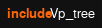Convert code to text. <code><loc_0><loc_0><loc_500><loc_500><_OCaml_>include Vp_tree
</code> 